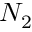Convert formula to latex. <formula><loc_0><loc_0><loc_500><loc_500>N _ { 2 }</formula> 